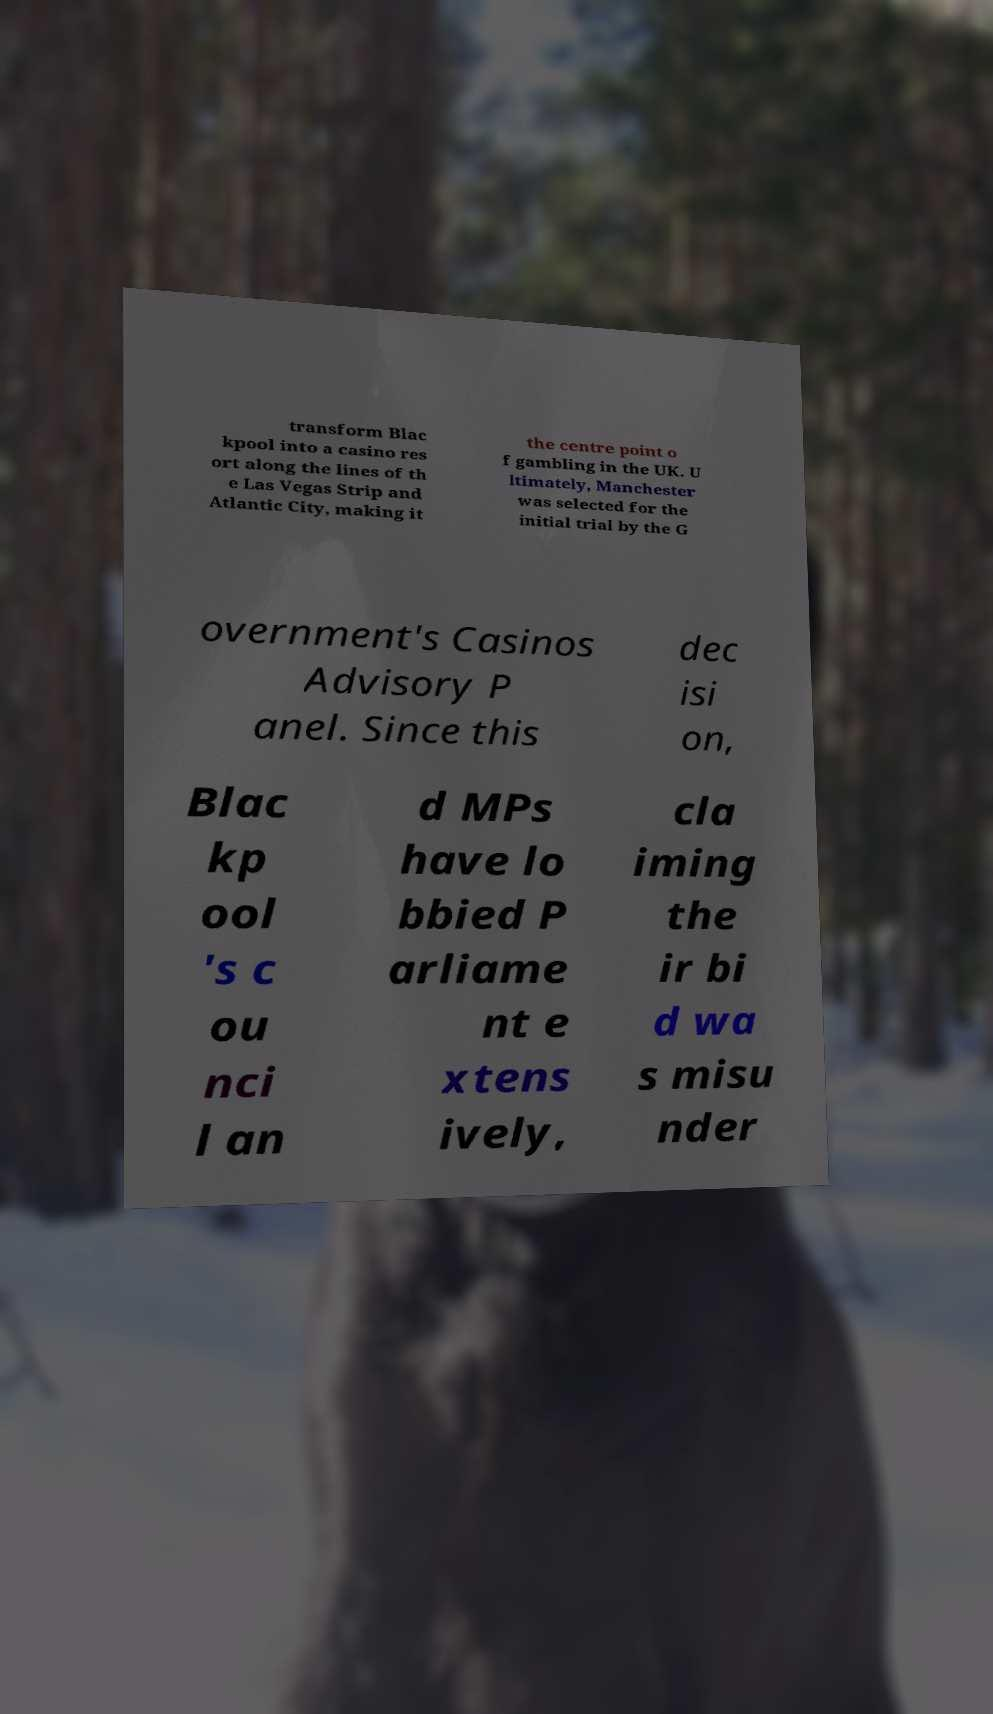Could you assist in decoding the text presented in this image and type it out clearly? transform Blac kpool into a casino res ort along the lines of th e Las Vegas Strip and Atlantic City, making it the centre point o f gambling in the UK. U ltimately, Manchester was selected for the initial trial by the G overnment's Casinos Advisory P anel. Since this dec isi on, Blac kp ool 's c ou nci l an d MPs have lo bbied P arliame nt e xtens ively, cla iming the ir bi d wa s misu nder 